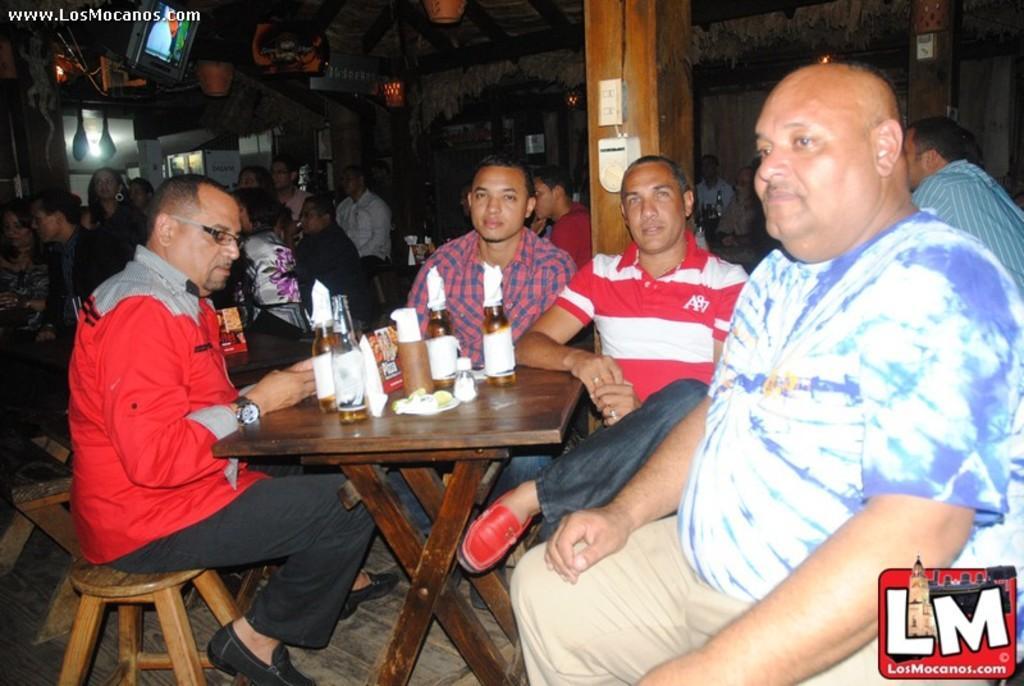Please provide a concise description of this image. In this image i can see few people sitting on chairs around the table, On the table i can see few glass bottles and few tissues. In the background i can see a pillar , a wall, and few other people sitting on chairs, a light and a television. 